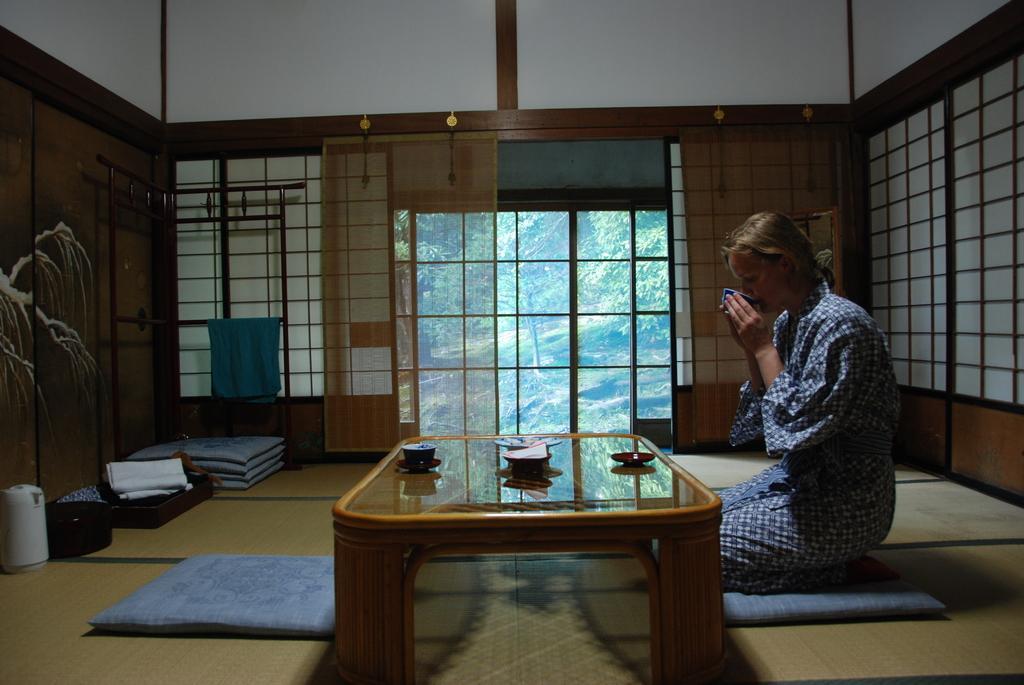Can you describe this image briefly? In this image I can see a woman is sitting on the right side, under here legs I can see a cushion. On the left side of this image I can see a table, few more cushions and few other stuffs on the ground. On the table I can see a plate, a cup and few other things. On the left side of this image I can see a blue colour cloth and in the background I can see number of trees. 